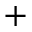<formula> <loc_0><loc_0><loc_500><loc_500>^ { + }</formula> 